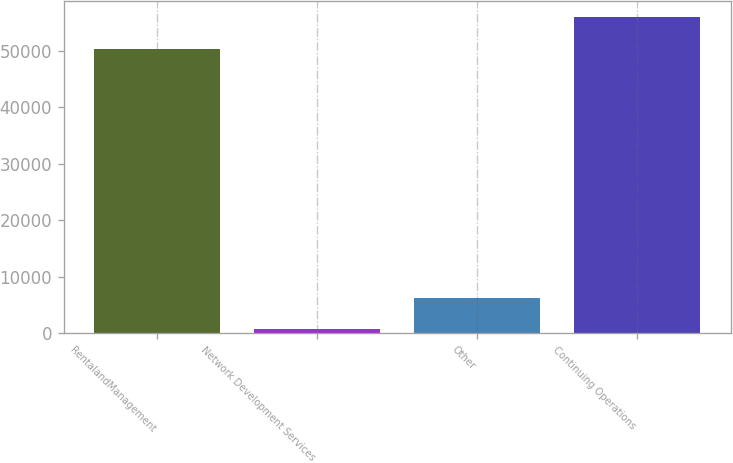Convert chart. <chart><loc_0><loc_0><loc_500><loc_500><bar_chart><fcel>RentalandManagement<fcel>Network Development Services<fcel>Other<fcel>Continuing Operations<nl><fcel>50336<fcel>741<fcel>6266.1<fcel>55992<nl></chart> 